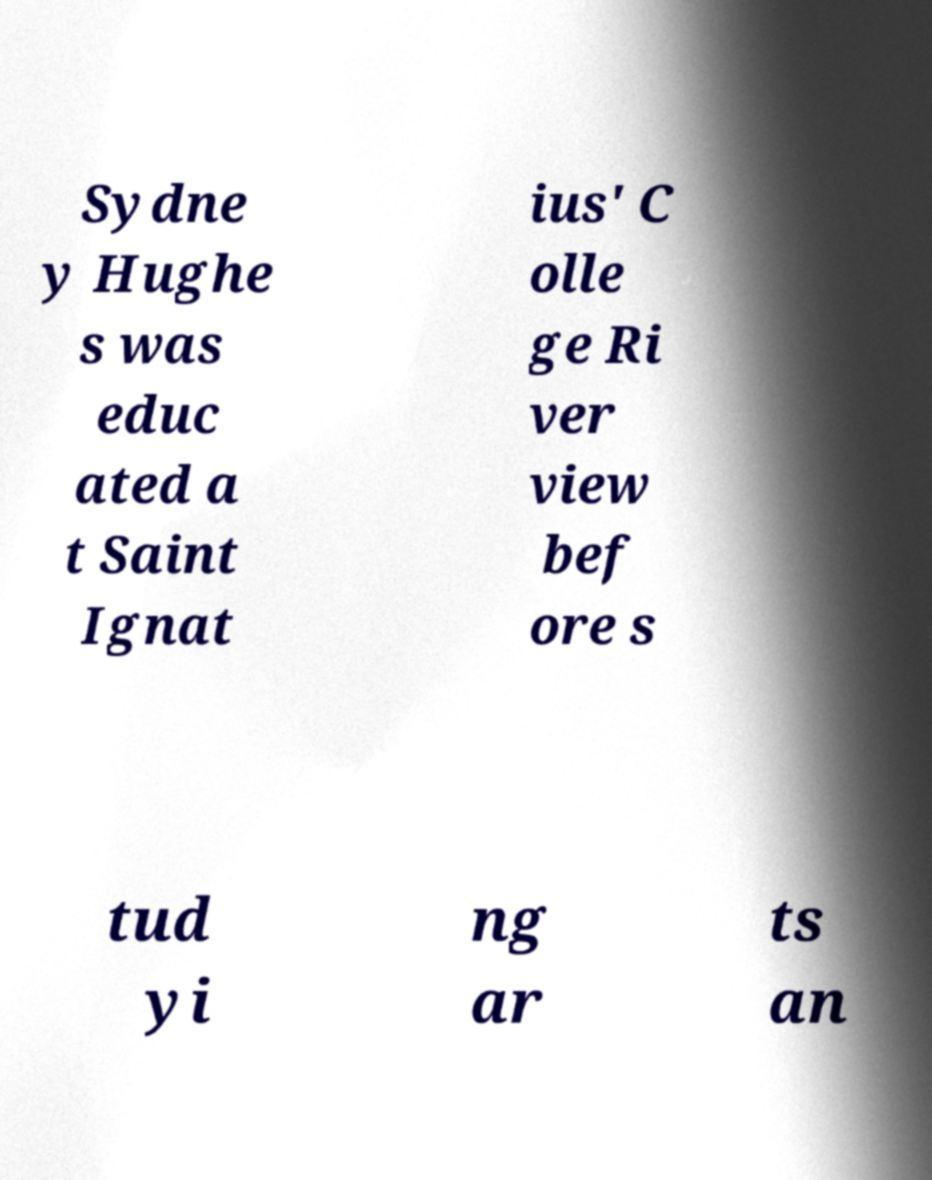Please identify and transcribe the text found in this image. Sydne y Hughe s was educ ated a t Saint Ignat ius' C olle ge Ri ver view bef ore s tud yi ng ar ts an 